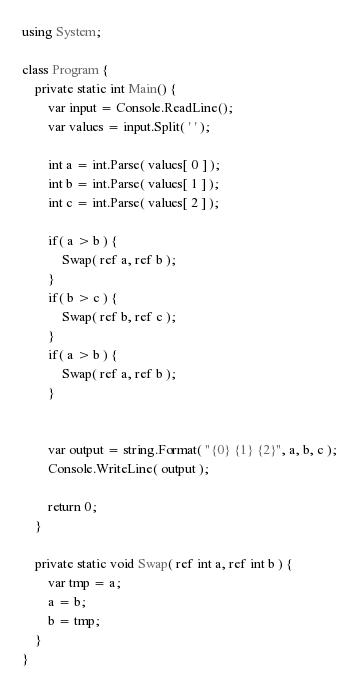<code> <loc_0><loc_0><loc_500><loc_500><_C#_>using System;

class Program {
    private static int Main() {
        var input = Console.ReadLine();
        var values = input.Split( ' ' );

        int a = int.Parse( values[ 0 ] );
        int b = int.Parse( values[ 1 ] );
        int c = int.Parse( values[ 2 ] );

        if( a > b ) {
            Swap( ref a, ref b );
        }
        if( b > c ) {
            Swap( ref b, ref c );
        }
        if( a > b ) {
            Swap( ref a, ref b );
        }


        var output = string.Format( "{0} {1} {2}", a, b, c );
        Console.WriteLine( output );

        return 0;
    }

    private static void Swap( ref int a, ref int b ) {
        var tmp = a;
        a = b;
        b = tmp;
    }
}</code> 